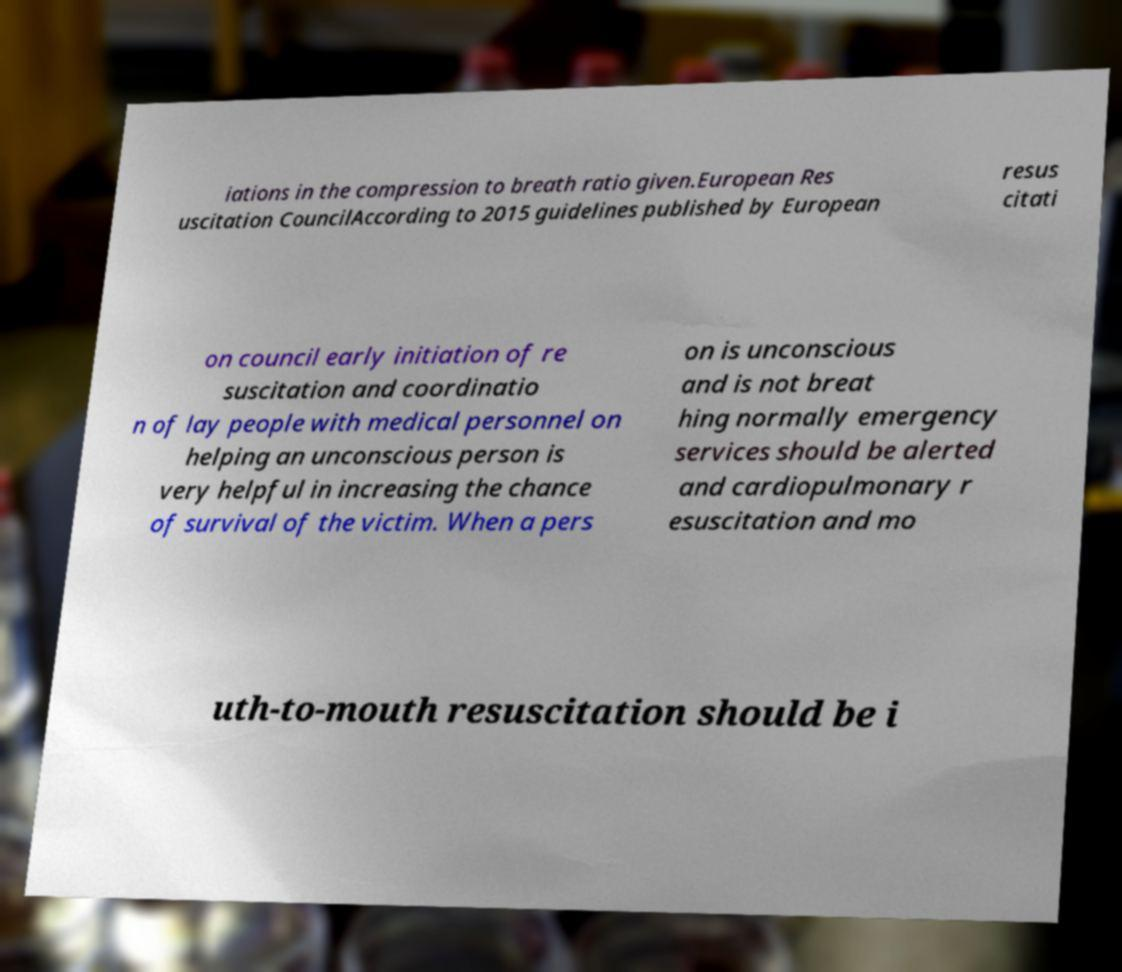Could you assist in decoding the text presented in this image and type it out clearly? iations in the compression to breath ratio given.European Res uscitation CouncilAccording to 2015 guidelines published by European resus citati on council early initiation of re suscitation and coordinatio n of lay people with medical personnel on helping an unconscious person is very helpful in increasing the chance of survival of the victim. When a pers on is unconscious and is not breat hing normally emergency services should be alerted and cardiopulmonary r esuscitation and mo uth-to-mouth resuscitation should be i 